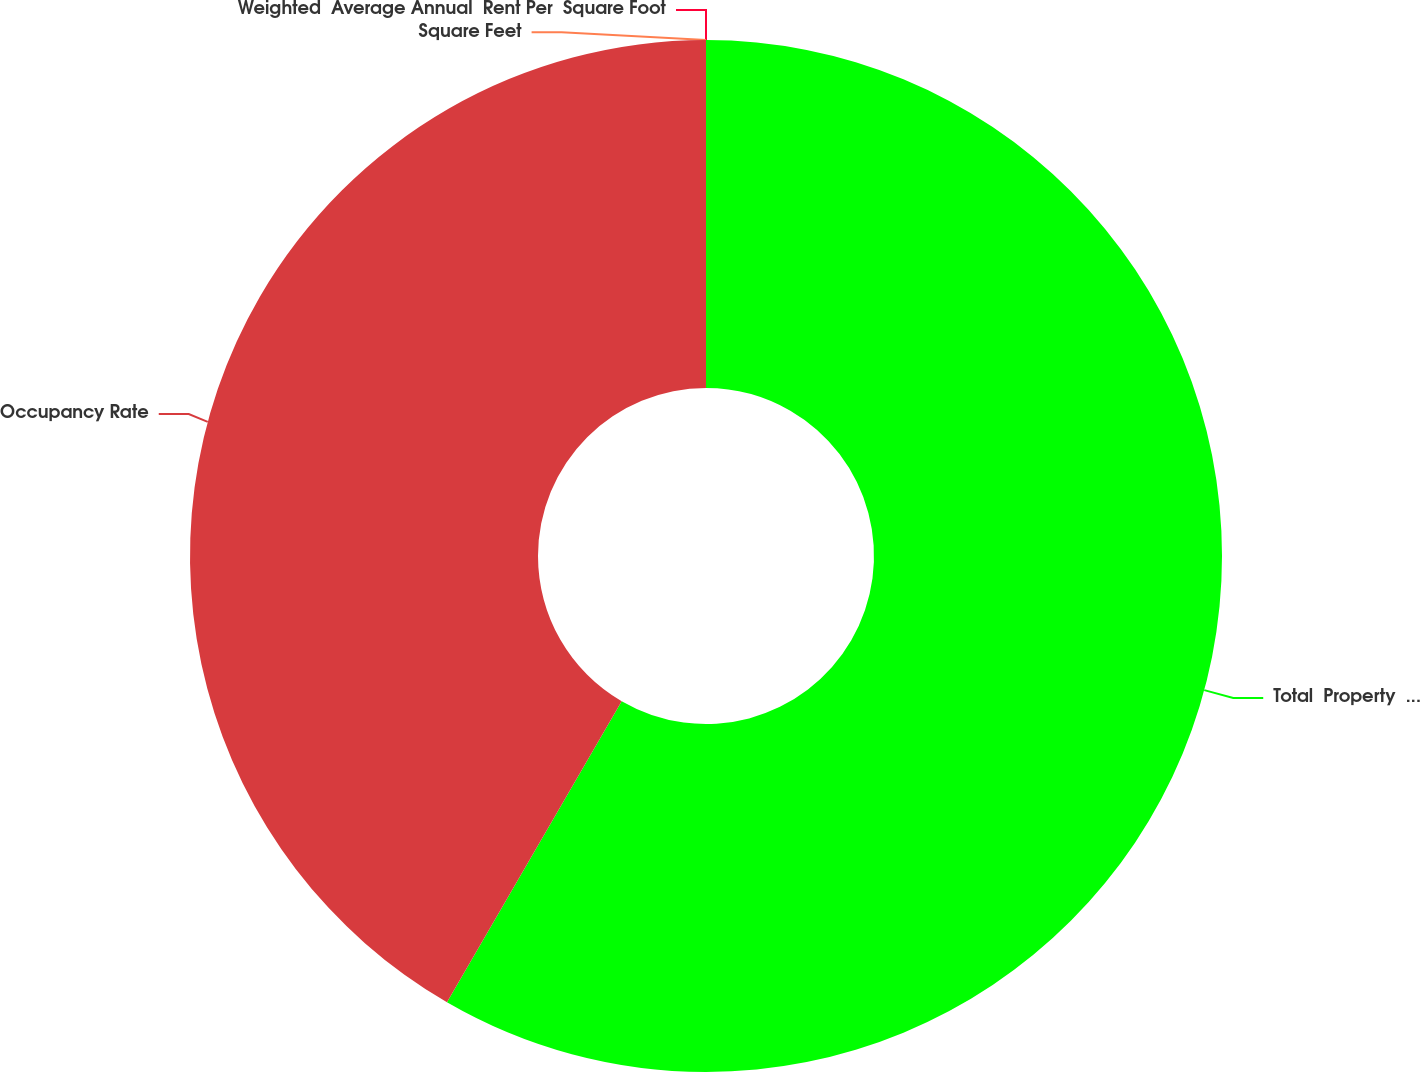Convert chart. <chart><loc_0><loc_0><loc_500><loc_500><pie_chart><fcel>Total  Property  Square Feet<fcel>Occupancy Rate<fcel>Weighted  Average Annual  Rent Per  Square Foot<fcel>Square Feet<nl><fcel>58.37%<fcel>41.63%<fcel>0.0%<fcel>0.0%<nl></chart> 